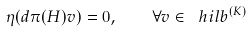Convert formula to latex. <formula><loc_0><loc_0><loc_500><loc_500>\eta ( d \pi ( H ) v ) = 0 , \quad \forall v \in \ h i l b ^ { ( K ) }</formula> 